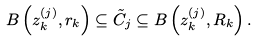<formula> <loc_0><loc_0><loc_500><loc_500>B \left ( z _ { k } ^ { ( j ) } , r _ { k } \right ) \subseteq \tilde { C } _ { j } \subseteq B \left ( z _ { k } ^ { ( j ) } , R _ { k } \right ) .</formula> 